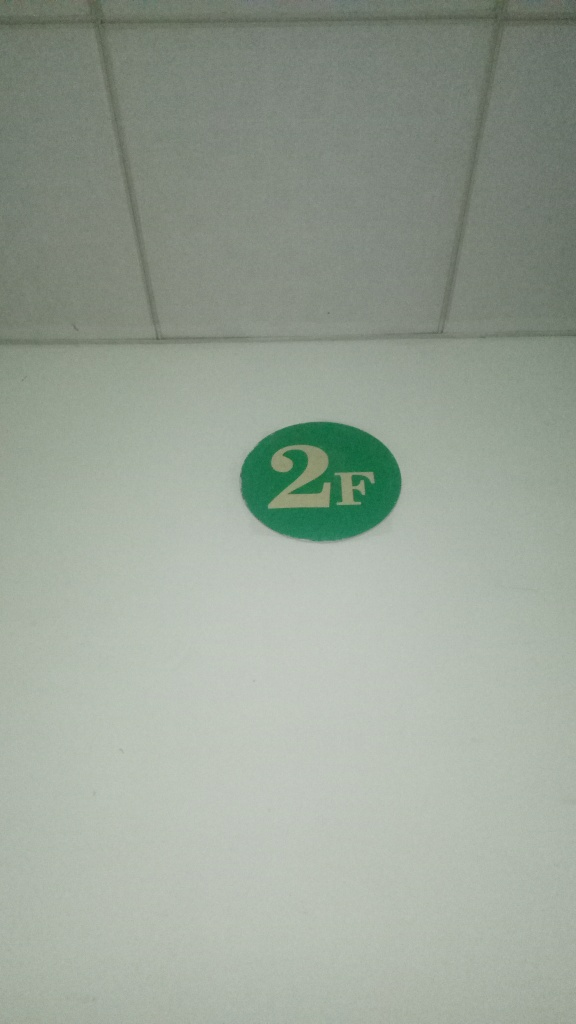What does the presence of this kind of signage typically say about the building? The presence of clearly marked floor signage, like this '2F' indicator, suggests that the building is likely structured in a way that requires guidance for navigation. This might be characteristic of a multi-story commercial or residential building, a hospital, an academic institution, or a public facility where visitors need to find their way to various departments or units efficiently. 